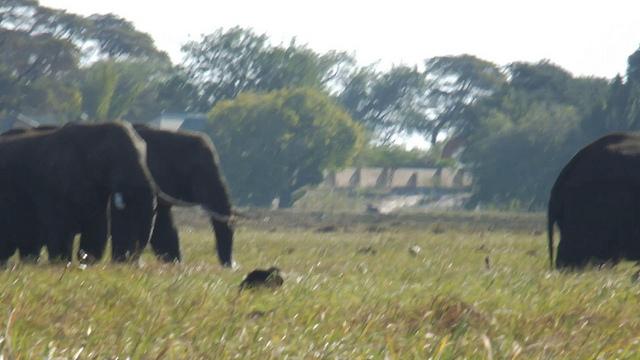Is the pasture haunted or are the white mists reflections?
Write a very short answer. Reflections. Are the elephants fully grown?
Write a very short answer. Yes. What animal is this?
Quick response, please. Elephant. What kind of animal is this?
Quick response, please. Elephant. Are the elephants in their natural habitat?
Keep it brief. Yes. How many elephants are there?
Quick response, please. 3. What color is the animal?
Give a very brief answer. Gray. Is this foto clear?
Quick response, please. No. What animals are here?
Give a very brief answer. Elephants. Are there mountains in the background?
Give a very brief answer. No. What is the house made out of?
Short answer required. Wood. What color are these animals?
Be succinct. Gray. Might one of these animals have the same name as a sort of negative behavior?
Answer briefly. No. Is the animal awake?
Short answer required. Yes. What are the tallest things in the photo?
Answer briefly. Trees. Does the animal appear to be relaxed?
Answer briefly. Yes. 